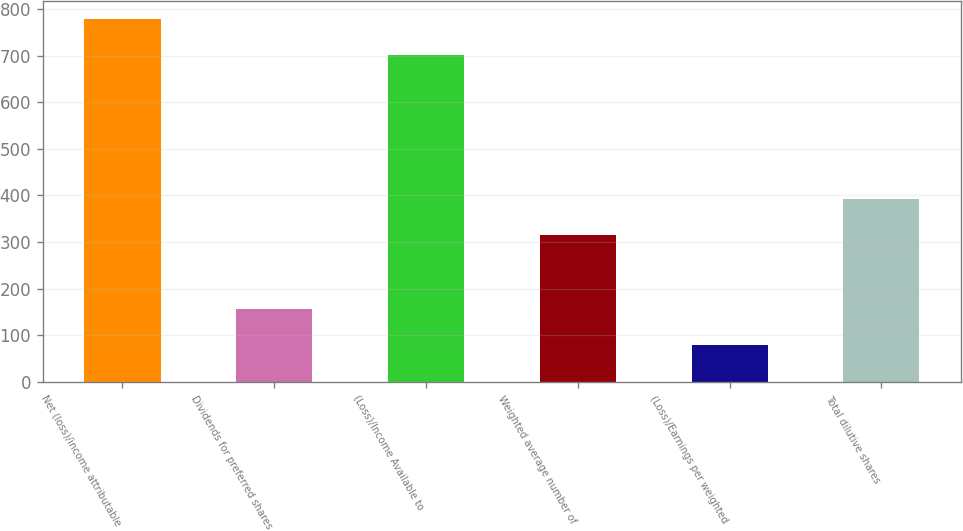<chart> <loc_0><loc_0><loc_500><loc_500><bar_chart><fcel>Net (loss)/income attributable<fcel>Dividends for preferred shares<fcel>(Loss)/Income Available to<fcel>Weighted average number of<fcel>(Loss)/Earnings per weighted<fcel>Total dilutive shares<nl><fcel>778.18<fcel>156.58<fcel>701<fcel>316<fcel>79.4<fcel>393.18<nl></chart> 